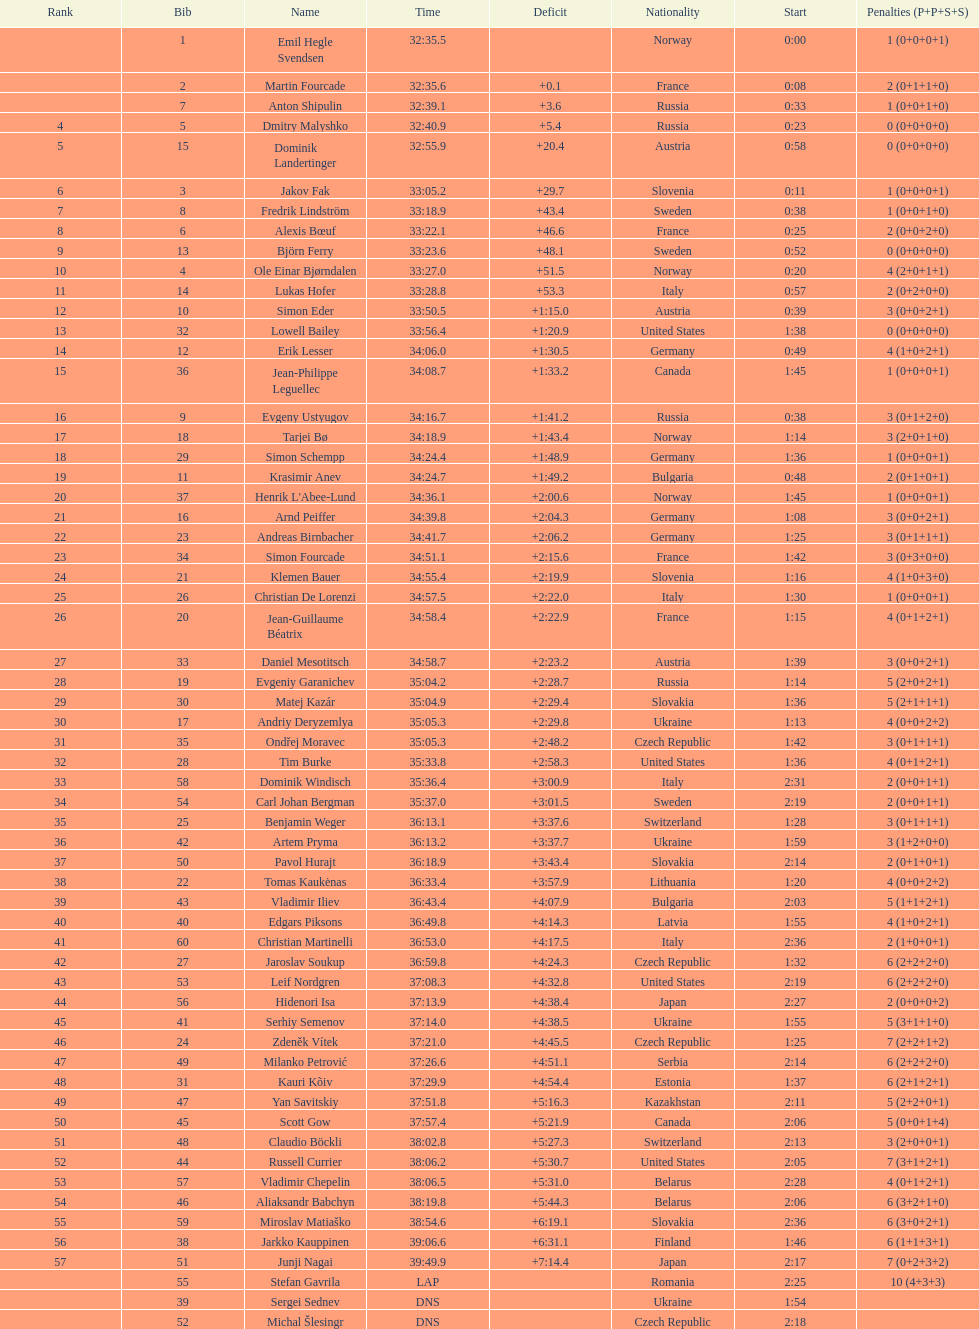What is the total number of penalties awarded to germany? 11. 